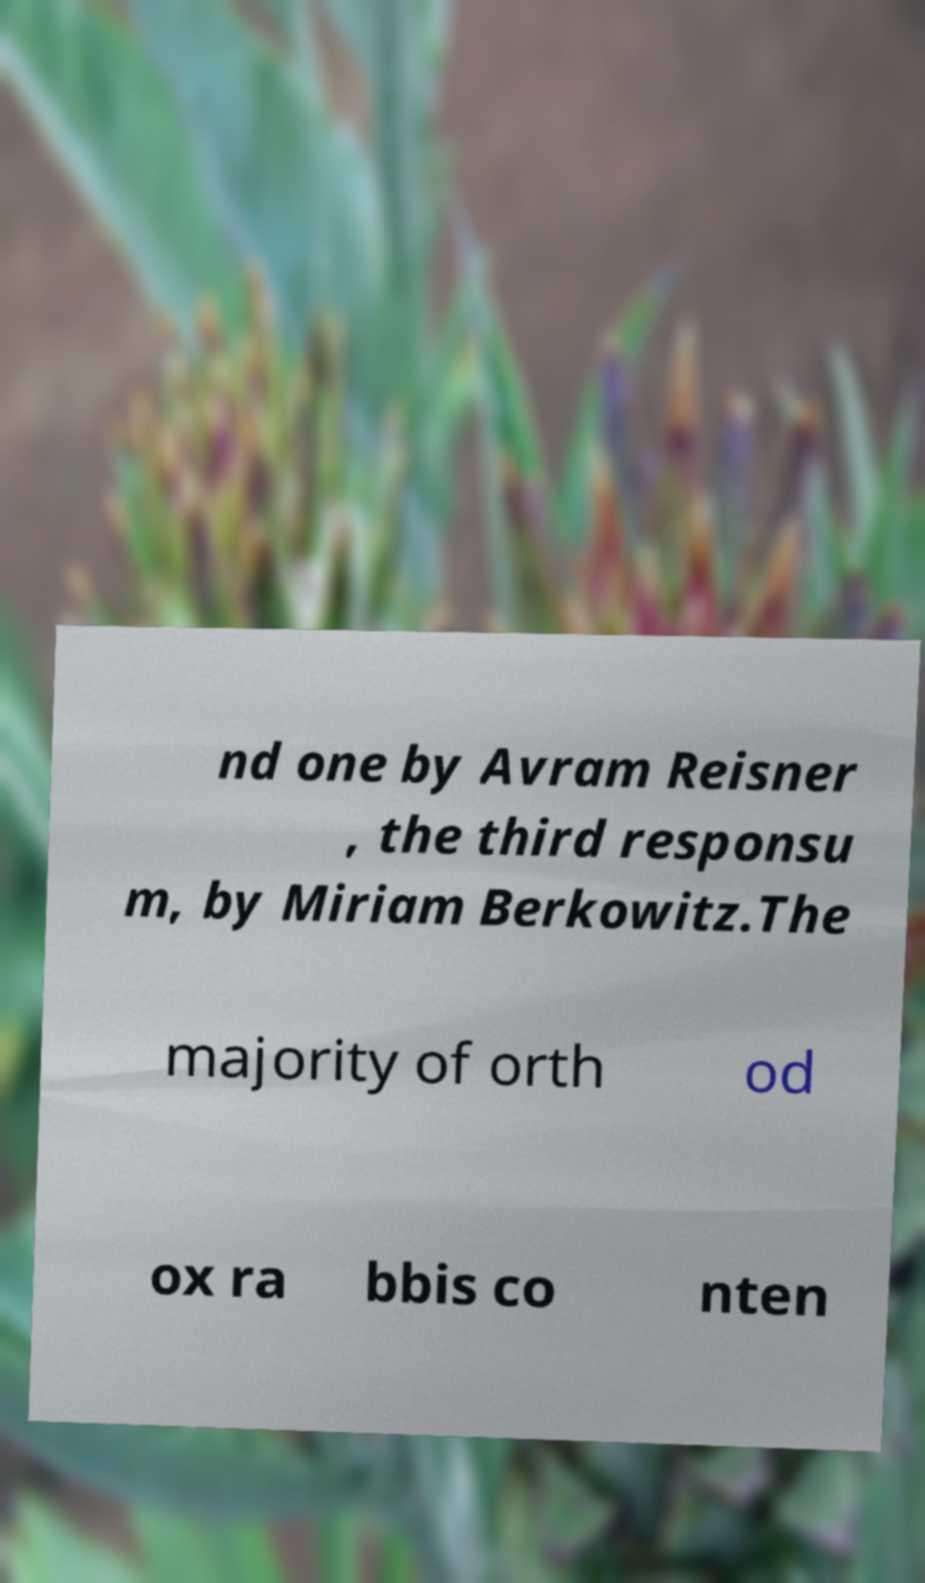What messages or text are displayed in this image? I need them in a readable, typed format. nd one by Avram Reisner , the third responsu m, by Miriam Berkowitz.The majority of orth od ox ra bbis co nten 